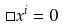Convert formula to latex. <formula><loc_0><loc_0><loc_500><loc_500>\Box x ^ { i } = 0</formula> 